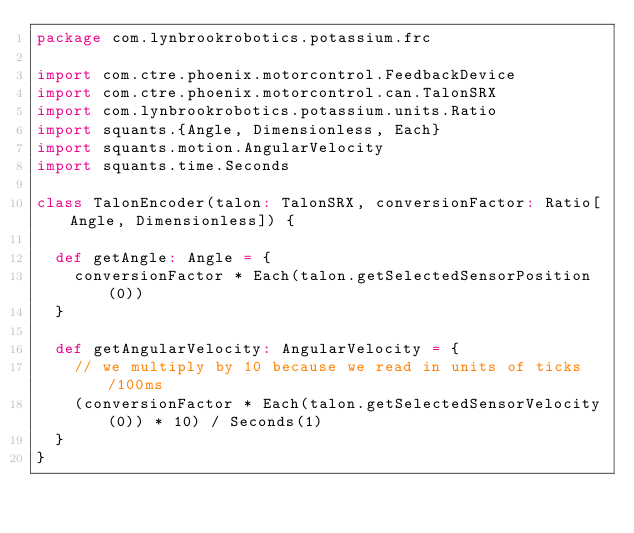Convert code to text. <code><loc_0><loc_0><loc_500><loc_500><_Scala_>package com.lynbrookrobotics.potassium.frc

import com.ctre.phoenix.motorcontrol.FeedbackDevice
import com.ctre.phoenix.motorcontrol.can.TalonSRX
import com.lynbrookrobotics.potassium.units.Ratio
import squants.{Angle, Dimensionless, Each}
import squants.motion.AngularVelocity
import squants.time.Seconds

class TalonEncoder(talon: TalonSRX, conversionFactor: Ratio[Angle, Dimensionless]) {

  def getAngle: Angle = {
    conversionFactor * Each(talon.getSelectedSensorPosition(0))
  }

  def getAngularVelocity: AngularVelocity = {
    // we multiply by 10 because we read in units of ticks/100ms
    (conversionFactor * Each(talon.getSelectedSensorVelocity(0)) * 10) / Seconds(1)
  }
}
</code> 